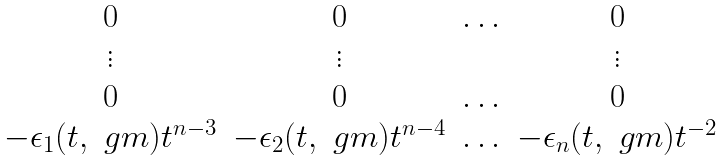Convert formula to latex. <formula><loc_0><loc_0><loc_500><loc_500>\begin{matrix} 0 & 0 & \hdots & 0 \\ \vdots & \vdots & & \vdots \\ 0 & 0 & \hdots & 0 \\ - \epsilon _ { 1 } ( t , \ g m ) t ^ { n - 3 } & - \epsilon _ { 2 } ( t , \ g m ) t ^ { n - 4 } & \hdots & - \epsilon _ { n } ( t , \ g m ) t ^ { - 2 } \end{matrix}</formula> 